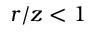Convert formula to latex. <formula><loc_0><loc_0><loc_500><loc_500>r / z < 1</formula> 